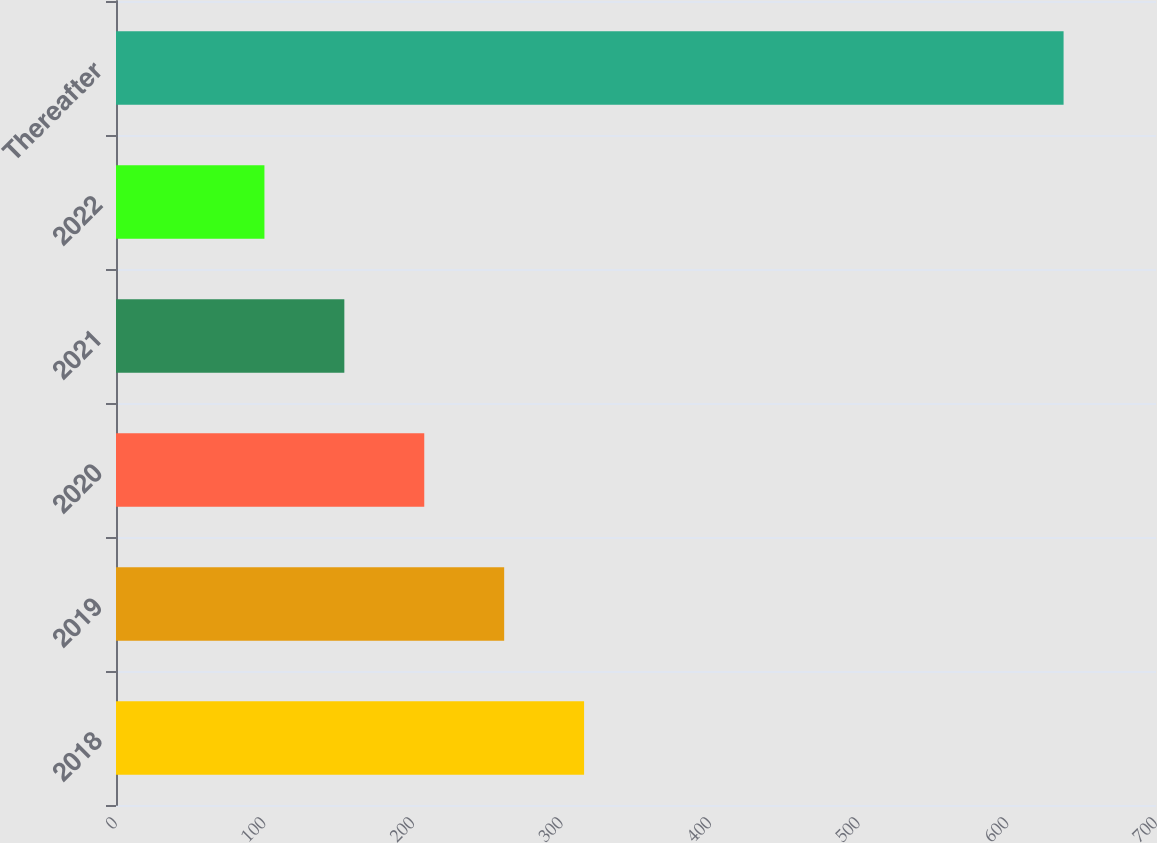<chart> <loc_0><loc_0><loc_500><loc_500><bar_chart><fcel>2018<fcel>2019<fcel>2020<fcel>2021<fcel>2022<fcel>Thereafter<nl><fcel>315.06<fcel>261.27<fcel>207.48<fcel>153.69<fcel>99.9<fcel>637.8<nl></chart> 